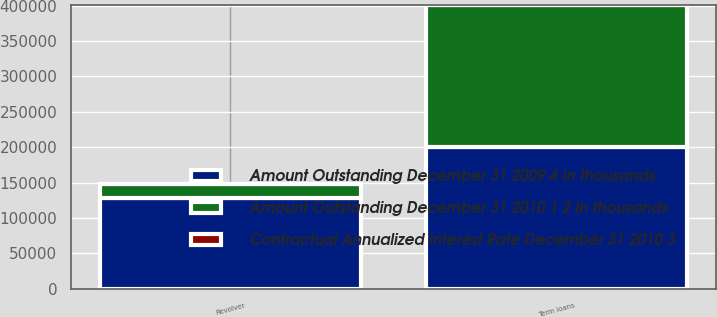<chart> <loc_0><loc_0><loc_500><loc_500><stacked_bar_chart><ecel><fcel>Term loans<fcel>Revolver<nl><fcel>Amount Outstanding December 31 2010 1 2 In thousands<fcel>200000<fcel>20156<nl><fcel>Contractual Annualized Interest Rate December 31 2010 3<fcel>2.3<fcel>2.26<nl><fcel>Amount Outstanding December 31 2009 4 In thousands<fcel>201000<fcel>128000<nl></chart> 